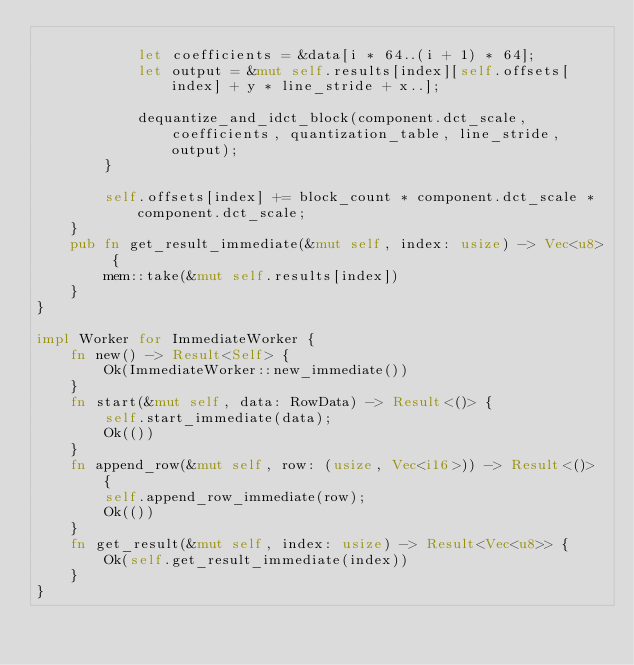<code> <loc_0><loc_0><loc_500><loc_500><_Rust_>
            let coefficients = &data[i * 64..(i + 1) * 64];
            let output = &mut self.results[index][self.offsets[index] + y * line_stride + x..];

            dequantize_and_idct_block(component.dct_scale, coefficients, quantization_table, line_stride, output);
        }

        self.offsets[index] += block_count * component.dct_scale * component.dct_scale;
    }
    pub fn get_result_immediate(&mut self, index: usize) -> Vec<u8> {
        mem::take(&mut self.results[index])
    }
}

impl Worker for ImmediateWorker {
    fn new() -> Result<Self> {
        Ok(ImmediateWorker::new_immediate())
    }
    fn start(&mut self, data: RowData) -> Result<()> {
        self.start_immediate(data);
        Ok(())
    }
    fn append_row(&mut self, row: (usize, Vec<i16>)) -> Result<()> {
        self.append_row_immediate(row);
        Ok(())
    }
    fn get_result(&mut self, index: usize) -> Result<Vec<u8>> {
        Ok(self.get_result_immediate(index))
    }
}
</code> 